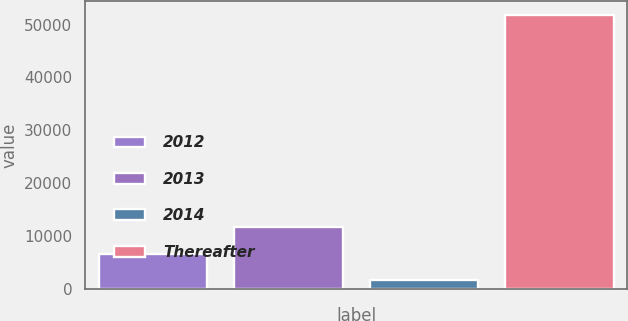Convert chart to OTSL. <chart><loc_0><loc_0><loc_500><loc_500><bar_chart><fcel>2012<fcel>2013<fcel>2014<fcel>Thereafter<nl><fcel>6632.4<fcel>11655.8<fcel>1609<fcel>51843<nl></chart> 